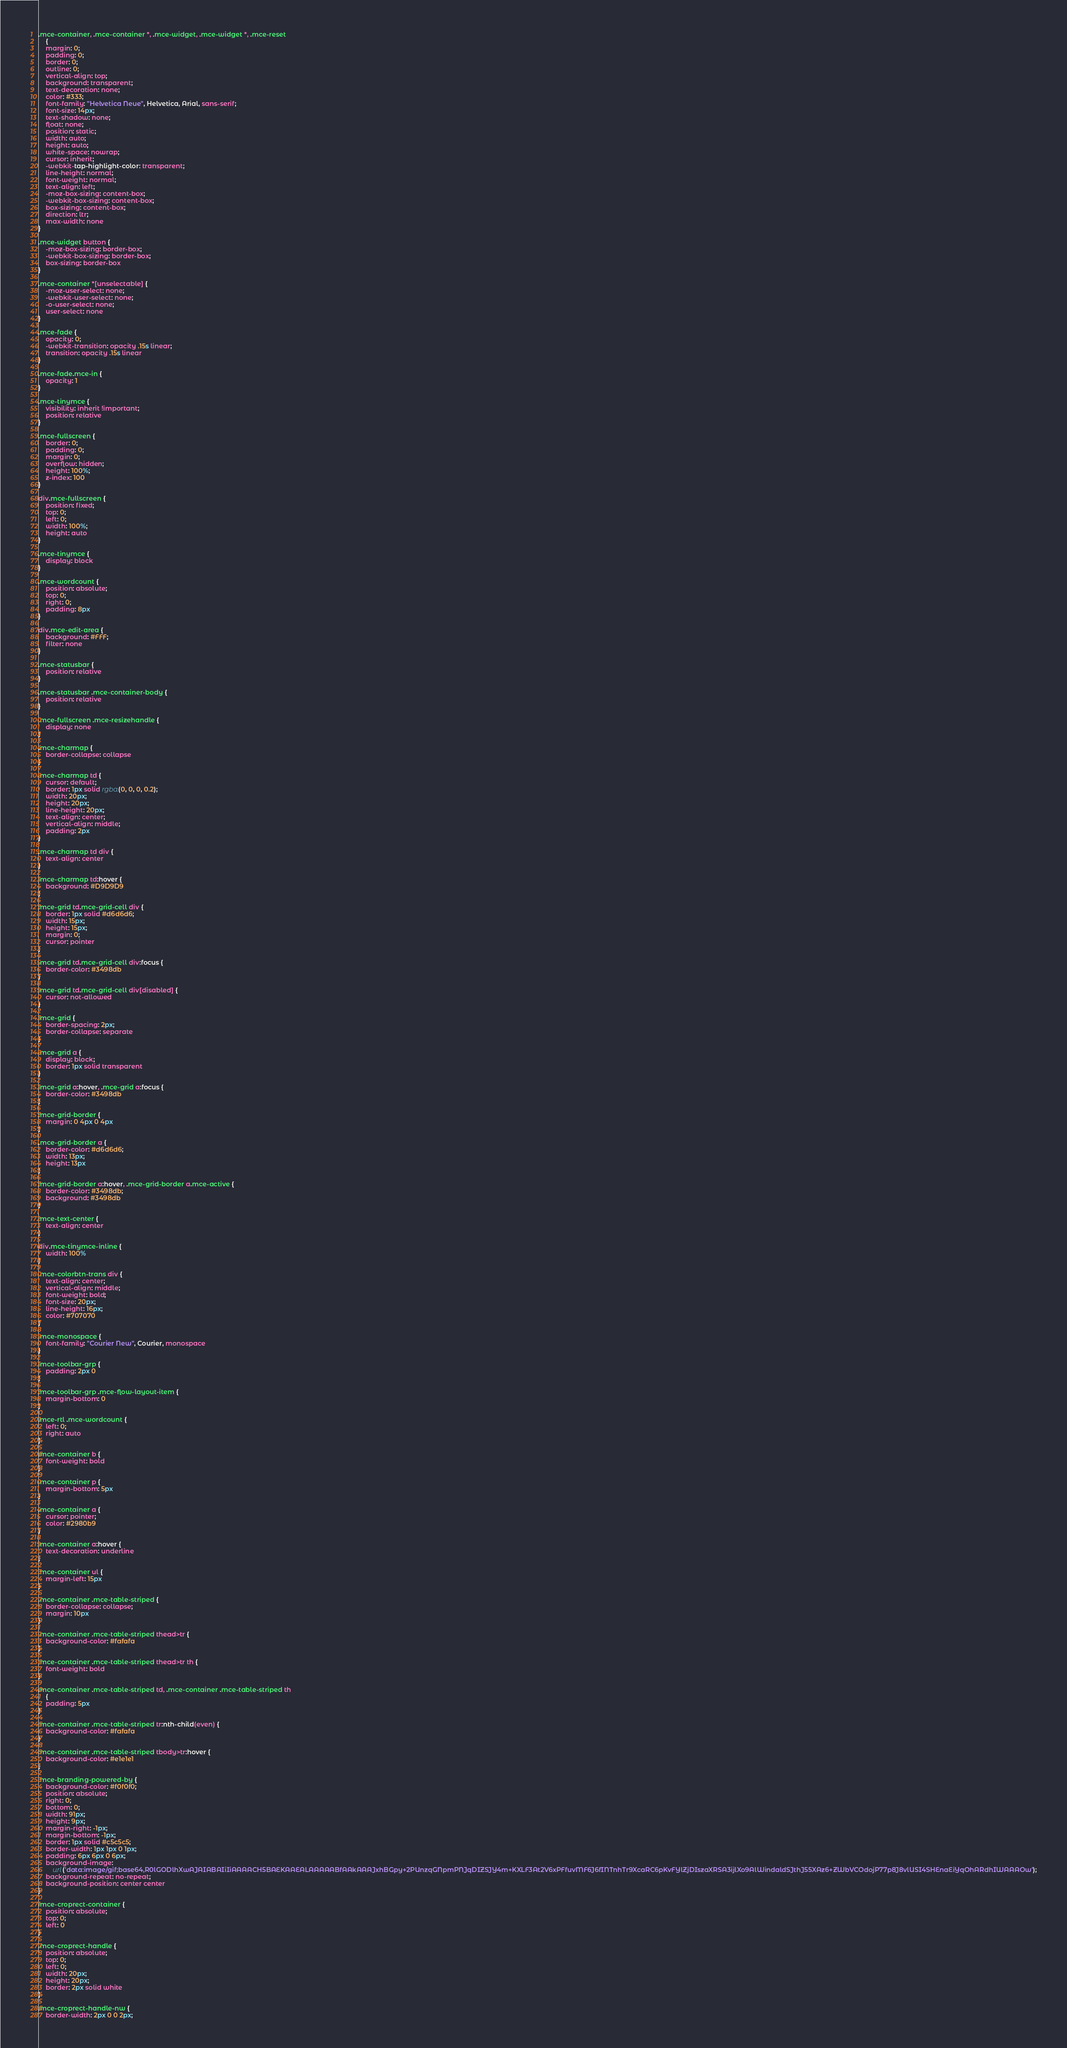<code> <loc_0><loc_0><loc_500><loc_500><_CSS_>.mce-container, .mce-container *, .mce-widget, .mce-widget *, .mce-reset
	{
	margin: 0;
	padding: 0;
	border: 0;
	outline: 0;
	vertical-align: top;
	background: transparent;
	text-decoration: none;
	color: #333;
	font-family: "Helvetica Neue", Helvetica, Arial, sans-serif;
	font-size: 14px;
	text-shadow: none;
	float: none;
	position: static;
	width: auto;
	height: auto;
	white-space: nowrap;
	cursor: inherit;
	-webkit-tap-highlight-color: transparent;
	line-height: normal;
	font-weight: normal;
	text-align: left;
	-moz-box-sizing: content-box;
	-webkit-box-sizing: content-box;
	box-sizing: content-box;
	direction: ltr;
	max-width: none
}

.mce-widget button {
	-moz-box-sizing: border-box;
	-webkit-box-sizing: border-box;
	box-sizing: border-box
}

.mce-container *[unselectable] {
	-moz-user-select: none;
	-webkit-user-select: none;
	-o-user-select: none;
	user-select: none
}

.mce-fade {
	opacity: 0;
	-webkit-transition: opacity .15s linear;
	transition: opacity .15s linear
}

.mce-fade.mce-in {
	opacity: 1
}

.mce-tinymce {
	visibility: inherit !important;
	position: relative
}

.mce-fullscreen {
	border: 0;
	padding: 0;
	margin: 0;
	overflow: hidden;
	height: 100%;
	z-index: 100
}

div.mce-fullscreen {
	position: fixed;
	top: 0;
	left: 0;
	width: 100%;
	height: auto
}

.mce-tinymce {
	display: block
}

.mce-wordcount {
	position: absolute;
	top: 0;
	right: 0;
	padding: 8px
}

div.mce-edit-area {
	background: #FFF;
	filter: none
}

.mce-statusbar {
	position: relative
}

.mce-statusbar .mce-container-body {
	position: relative
}

.mce-fullscreen .mce-resizehandle {
	display: none
}

.mce-charmap {
	border-collapse: collapse
}

.mce-charmap td {
	cursor: default;
	border: 1px solid rgba(0, 0, 0, 0.2);
	width: 20px;
	height: 20px;
	line-height: 20px;
	text-align: center;
	vertical-align: middle;
	padding: 2px
}

.mce-charmap td div {
	text-align: center
}

.mce-charmap td:hover {
	background: #D9D9D9
}

.mce-grid td.mce-grid-cell div {
	border: 1px solid #d6d6d6;
	width: 15px;
	height: 15px;
	margin: 0;
	cursor: pointer
}

.mce-grid td.mce-grid-cell div:focus {
	border-color: #3498db
}

.mce-grid td.mce-grid-cell div[disabled] {
	cursor: not-allowed
}

.mce-grid {
	border-spacing: 2px;
	border-collapse: separate
}

.mce-grid a {
	display: block;
	border: 1px solid transparent
}

.mce-grid a:hover, .mce-grid a:focus {
	border-color: #3498db
}

.mce-grid-border {
	margin: 0 4px 0 4px
}

.mce-grid-border a {
	border-color: #d6d6d6;
	width: 13px;
	height: 13px
}

.mce-grid-border a:hover, .mce-grid-border a.mce-active {
	border-color: #3498db;
	background: #3498db
}

.mce-text-center {
	text-align: center
}

div.mce-tinymce-inline {
	width: 100%
}

.mce-colorbtn-trans div {
	text-align: center;
	vertical-align: middle;
	font-weight: bold;
	font-size: 20px;
	line-height: 16px;
	color: #707070
}

.mce-monospace {
	font-family: "Courier New", Courier, monospace
}

.mce-toolbar-grp {
	padding: 2px 0
}

.mce-toolbar-grp .mce-flow-layout-item {
	margin-bottom: 0
}

.mce-rtl .mce-wordcount {
	left: 0;
	right: auto
}

.mce-container b {
	font-weight: bold
}

.mce-container p {
	margin-bottom: 5px
}

.mce-container a {
	cursor: pointer;
	color: #2980b9
}

.mce-container a:hover {
	text-decoration: underline
}

.mce-container ul {
	margin-left: 15px
}

.mce-container .mce-table-striped {
	border-collapse: collapse;
	margin: 10px
}

.mce-container .mce-table-striped thead>tr {
	background-color: #fafafa
}

.mce-container .mce-table-striped thead>tr th {
	font-weight: bold
}

.mce-container .mce-table-striped td, .mce-container .mce-table-striped th
	{
	padding: 5px
}

.mce-container .mce-table-striped tr:nth-child(even) {
	background-color: #fafafa
}

.mce-container .mce-table-striped tbody>tr:hover {
	background-color: #e1e1e1
}

.mce-branding-powered-by {
	background-color: #f0f0f0;
	position: absolute;
	right: 0;
	bottom: 0;
	width: 91px;
	height: 9px;
	margin-right: -1px;
	margin-bottom: -1px;
	border: 1px solid #c5c5c5;
	border-width: 1px 1px 0 1px;
	padding: 6px 6px 0 6px;
	background-image:
		url('data:image/gif;base64,R0lGODlhXwAJAIABAIiIiAAAACH5BAEKAAEALAAAAABfAAkAAAJxhBGpy+2PUnzqGNpmPNJqDIZSJY4m+KXLF3At2V6xPFfuvMF6J6fINTnhTr9XcaRC6pKvFYlZjDIszaXRSA3ijlXo9AlWindaldSJthJ55XAz6+ZWbVCOdojP77p8J8vlUSI4SHEnaEiYqOhARdhIWAAAOw');
	background-repeat: no-repeat;
	background-position: center center
}

.mce-croprect-container {
	position: absolute;
	top: 0;
	left: 0
}

.mce-croprect-handle {
	position: absolute;
	top: 0;
	left: 0;
	width: 20px;
	height: 20px;
	border: 2px solid white
}

.mce-croprect-handle-nw {
	border-width: 2px 0 0 2px;</code> 